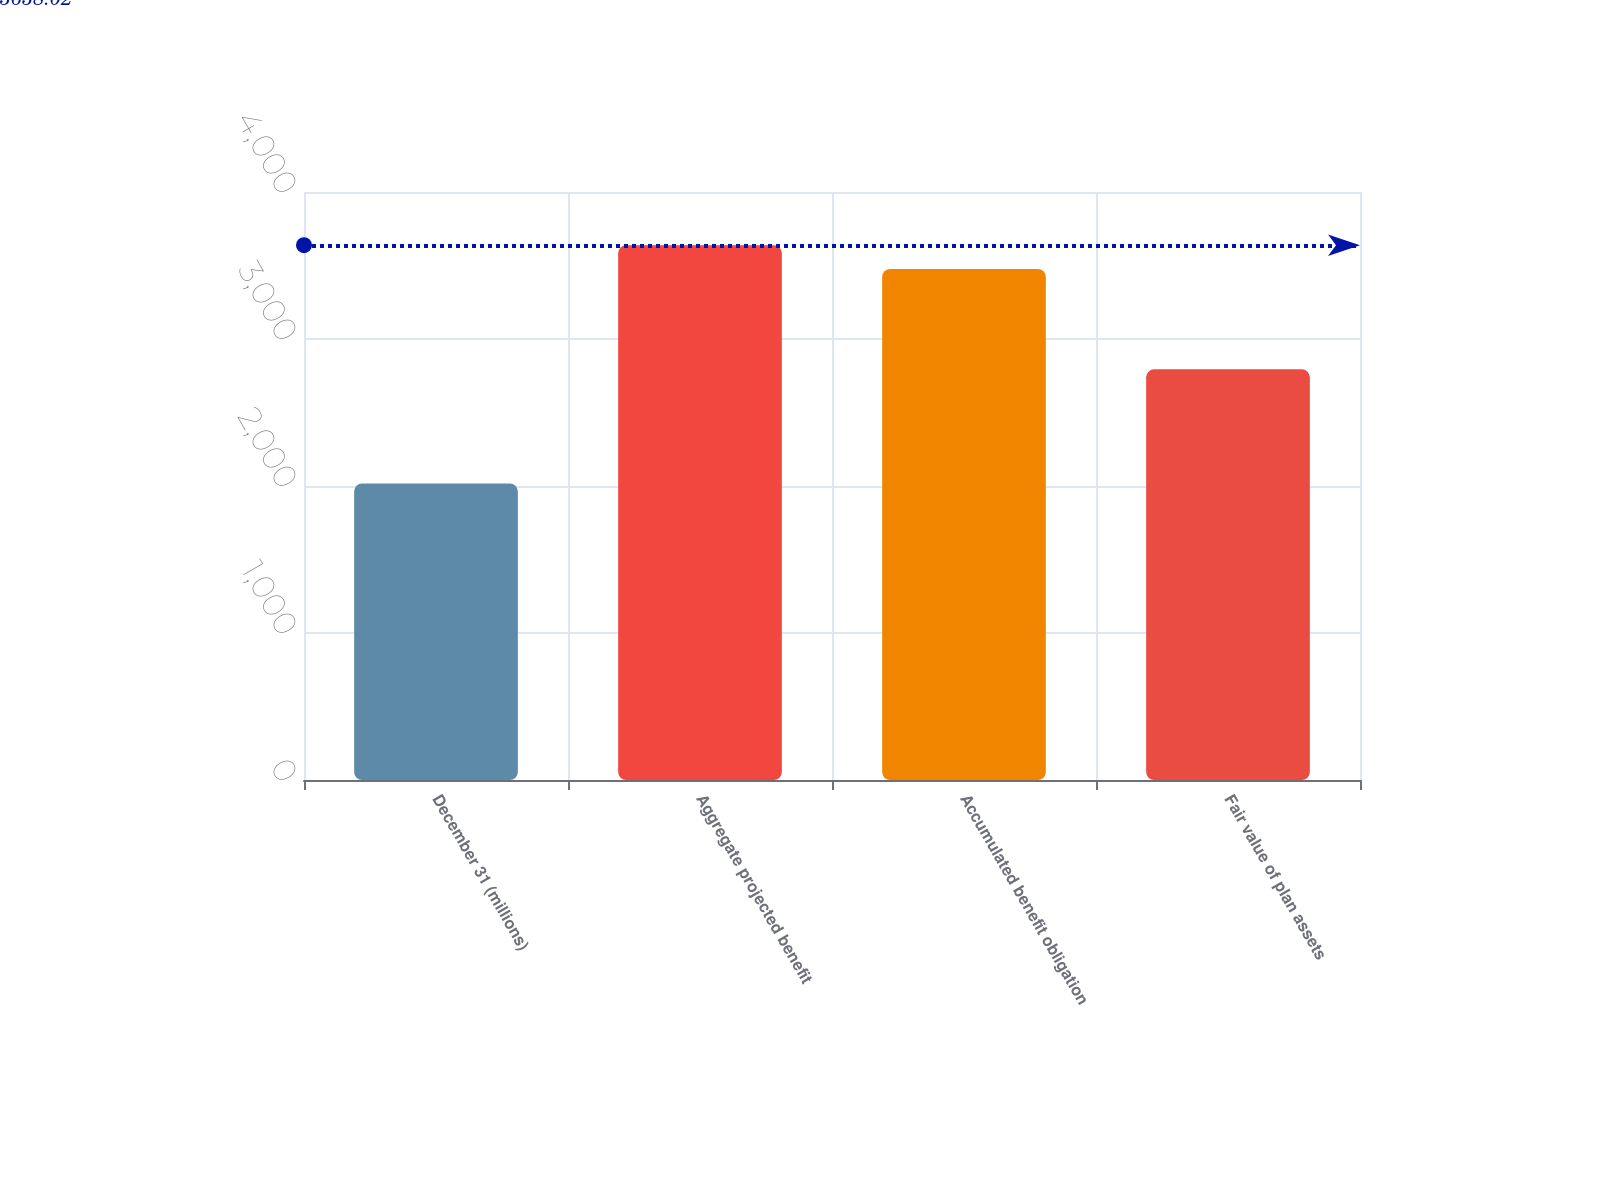Convert chart. <chart><loc_0><loc_0><loc_500><loc_500><bar_chart><fcel>December 31 (millions)<fcel>Aggregate projected benefit<fcel>Accumulated benefit obligation<fcel>Fair value of plan assets<nl><fcel>2017<fcel>3638.02<fcel>3476.1<fcel>2794<nl></chart> 